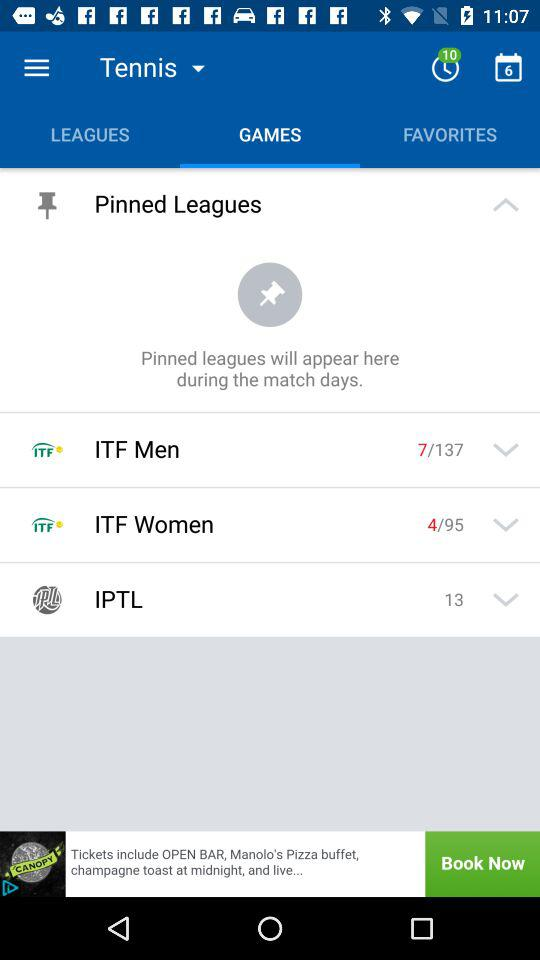What is the selected date? The date is 6. 